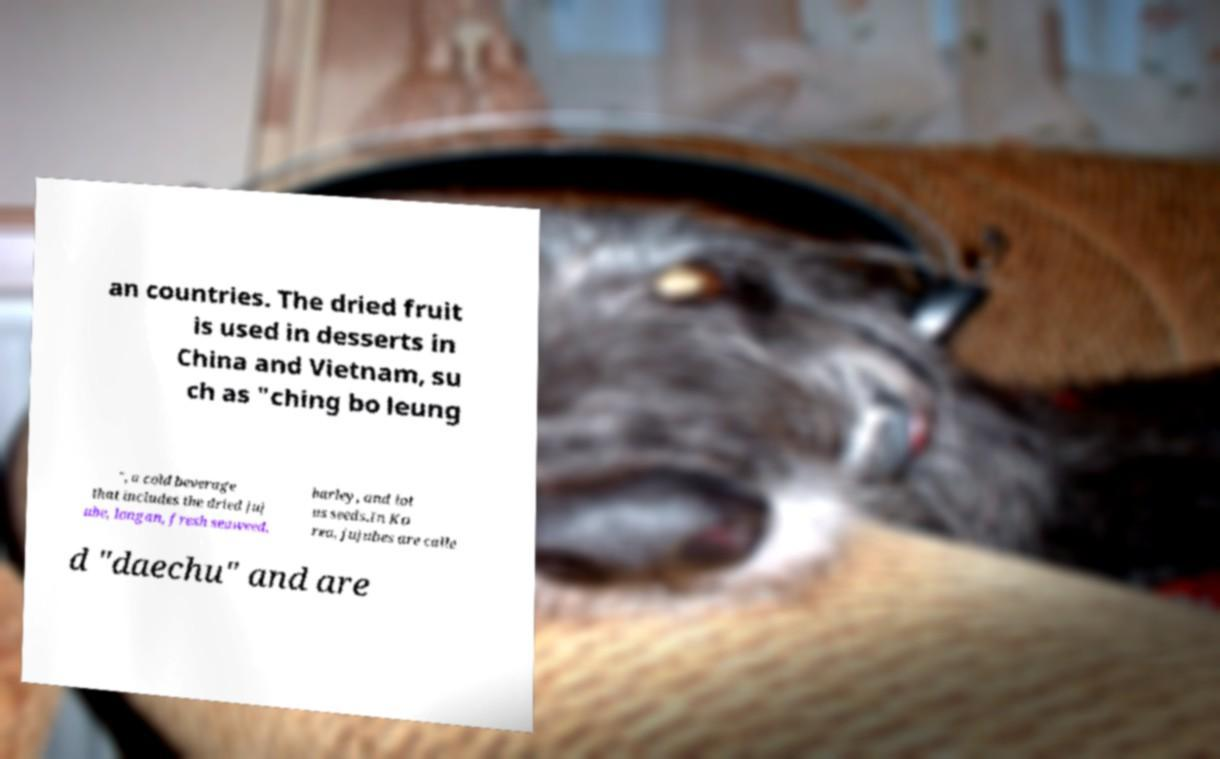Could you extract and type out the text from this image? an countries. The dried fruit is used in desserts in China and Vietnam, su ch as "ching bo leung ", a cold beverage that includes the dried juj ube, longan, fresh seaweed, barley, and lot us seeds.In Ko rea, jujubes are calle d "daechu" and are 